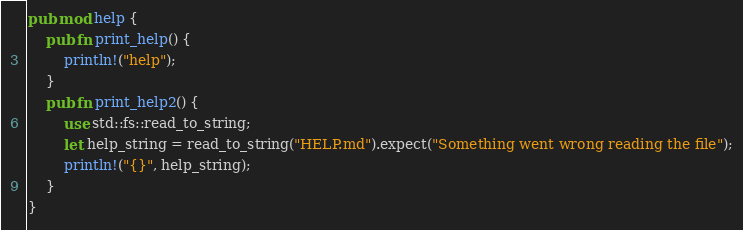<code> <loc_0><loc_0><loc_500><loc_500><_Rust_>pub mod help {
    pub fn print_help() {
        println!("help");
    }
    pub fn print_help2() {
        use std::fs::read_to_string;
        let help_string = read_to_string("HELP.md").expect("Something went wrong reading the file");
        println!("{}", help_string);
    }
}
</code> 